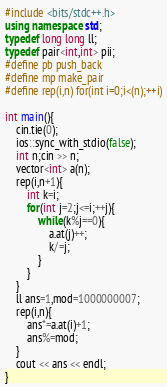<code> <loc_0><loc_0><loc_500><loc_500><_C++_>#include <bits/stdc++.h>
using namespace std;
typedef long long ll;
typedef pair<int,int> pii;
#define pb push_back
#define mp make_pair
#define rep(i,n) for(int i=0;i<(n);++i)

int main(){
	cin.tie(0);
	ios::sync_with_stdio(false);
	int n;cin >> n;
	vector<int> a(n);
	rep(i,n+1){
		int k=i;
		for(int j=2;j<=i;++j){
			while(k%j==0){
				a.at(j)++;
				k/=j;
			}
		}
	}
	ll ans=1,mod=1000000007;
	rep(i,n){
		ans*=a.at(i)+1;
		ans%=mod;
	}
	cout << ans << endl;
}</code> 